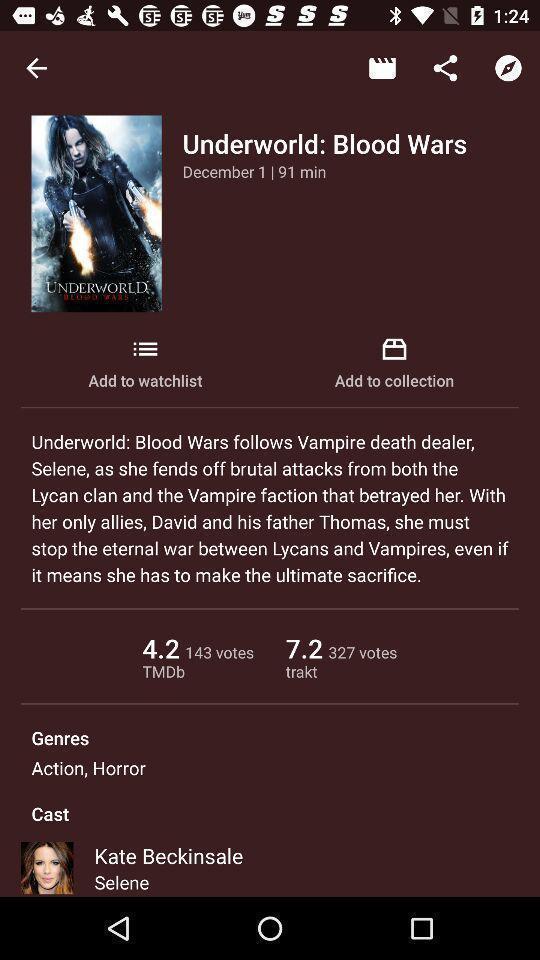What details can you identify in this image? Screen shows movie details in an entertainment app. 